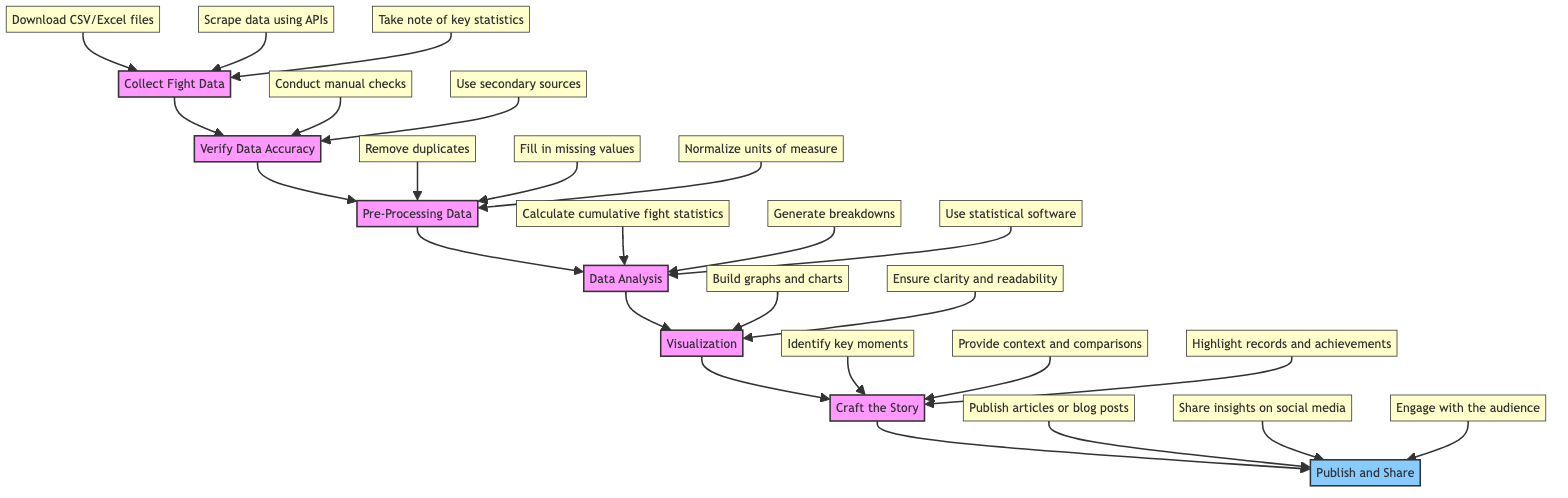What is the first step in the flowchart? The diagram indicates that "Collect Fight Data" is the first step, as it is the first node in the flow sequence.
Answer: Collect Fight Data How many detail nodes are associated with "Data Analysis"? The flow chart shows three detail nodes that branch off from "Data Analysis," indicating the various aspects of data analysis.
Answer: 3 What follows "Visualization" in the diagram? The next step after "Visualization" is "Craft the Story," illustrating the sequential flow of the process.
Answer: Craft the Story What is the last step outlined in the flowchart? According to the final node in the flowchart, the last step is "Publish and Share," which wraps up the instruction process.
Answer: Publish and Share Which step includes checking data against other sources? The step titled "Verify Data Accuracy" involves checking data against other reliable sources for validation.
Answer: Verify Data Accuracy How many total steps are in the flowchart? The flowchart consists of a total of seven main steps, each indicating a part of the instruction process.
Answer: 7 Which detail node under "Craft the Story" contains the phrase "key moments"? The detail node labeled "Identify key moments" is under "Craft the Story," emphasizing its importance in storytelling.
Answer: Identify key moments What is the purpose of the "Pre-Processing Data" step? "Pre-Processing Data" is meant to clean and prepare the data for analysis, addressing inconsistencies and incomplete entries.
Answer: Clean and prepare data What is one tool mentioned for creating visualizations? The diagram mentions several tools for visualization, including Tableau, Power BI, and Matplotlib, highlighting their use in graphing data.
Answer: Tableau 